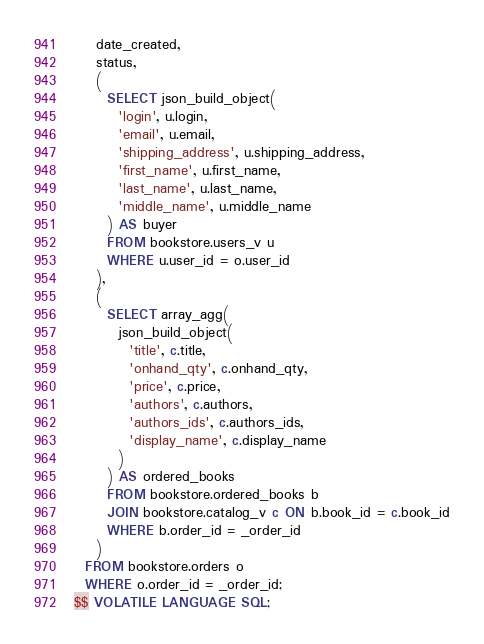Convert code to text. <code><loc_0><loc_0><loc_500><loc_500><_SQL_>    date_created,
    status,
    (
      SELECT json_build_object(
        'login', u.login,
        'email', u.email,
        'shipping_address', u.shipping_address,
        'first_name', u.first_name,
        'last_name', u.last_name,
        'middle_name', u.middle_name
      ) AS buyer
      FROM bookstore.users_v u
      WHERE u.user_id = o.user_id
    ),
    (
      SELECT array_agg(
        json_build_object(
          'title', c.title,
          'onhand_qty', c.onhand_qty,
          'price', c.price,
          'authors', c.authors,
          'authors_ids', c.authors_ids,
          'display_name', c.display_name
        )
      ) AS ordered_books
      FROM bookstore.ordered_books b
      JOIN bookstore.catalog_v c ON b.book_id = c.book_id
      WHERE b.order_id = _order_id
    )
  FROM bookstore.orders o
  WHERE o.order_id = _order_id;
$$ VOLATILE LANGUAGE SQL;
</code> 